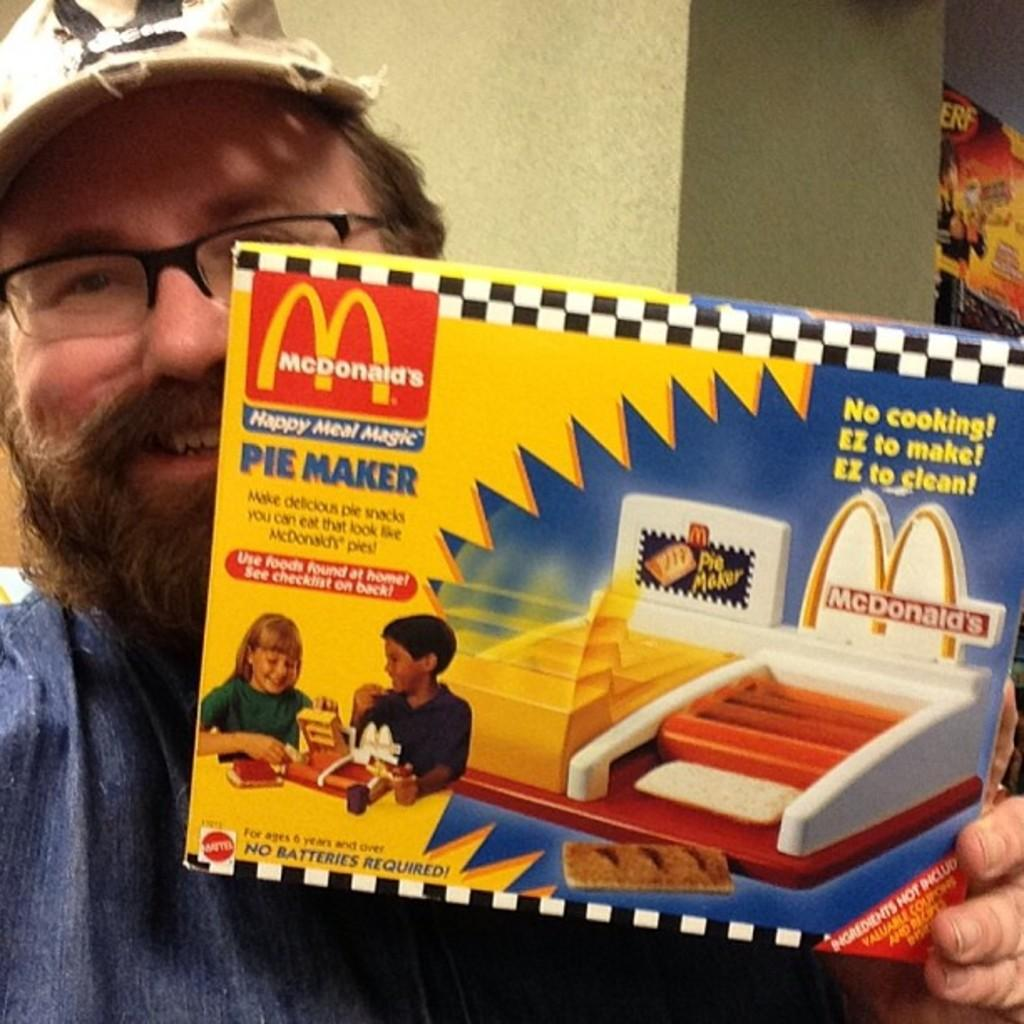What is the man in the image holding? The man is holding a box in the image. What is inside the box that the man is holding? The box contains pictures and text. What can be seen behind the man in the image? There is a wall visible in the image. What is on the wall in the image? There is a poster on the wall. Can you see a rabbit walking on a trail in the image? There is no rabbit or trail present in the image. 